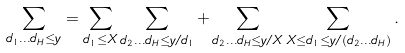Convert formula to latex. <formula><loc_0><loc_0><loc_500><loc_500>\sum _ { d _ { 1 } \dots d _ { H } \leq y } = \sum _ { d _ { 1 } \leq X } \sum _ { d _ { 2 } \dots d _ { H } \leq y / d _ { 1 } } + \sum _ { d _ { 2 } \dots d _ { H } \leq y / X } \sum _ { X \leq d _ { 1 } \leq y / ( d _ { 2 } \dots d _ { H } ) } .</formula> 